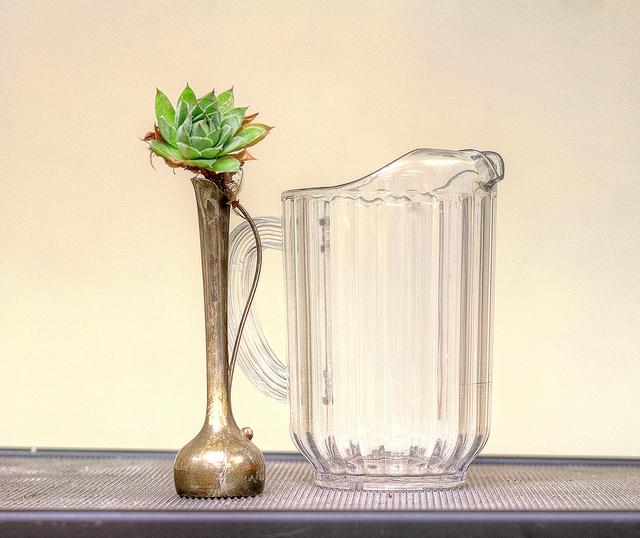What is the object next to the flower?
Be succinct. Pitcher. What color is the flower in the silver vase?
Concise answer only. Green. Are these fragile objects?
Concise answer only. Yes. Will the flower live long here?
Be succinct. No. Is the object on the left shorter?
Be succinct. No. Is there water in the pitcher?
Keep it brief. No. 